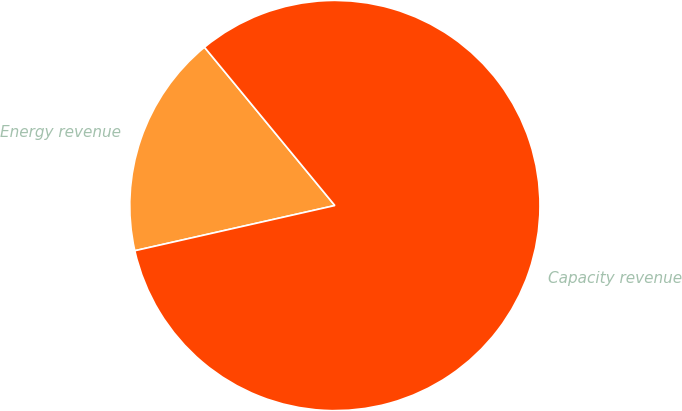Convert chart to OTSL. <chart><loc_0><loc_0><loc_500><loc_500><pie_chart><fcel>Energy revenue<fcel>Capacity revenue<nl><fcel>17.57%<fcel>82.43%<nl></chart> 